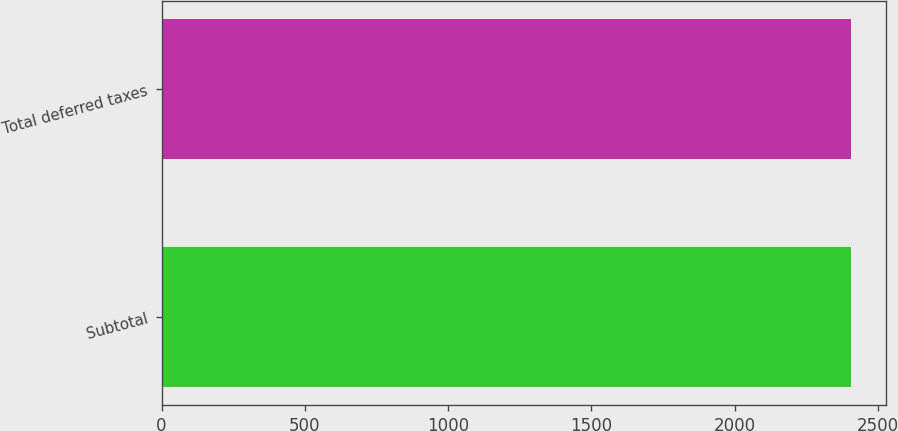Convert chart. <chart><loc_0><loc_0><loc_500><loc_500><bar_chart><fcel>Subtotal<fcel>Total deferred taxes<nl><fcel>2406<fcel>2406.1<nl></chart> 